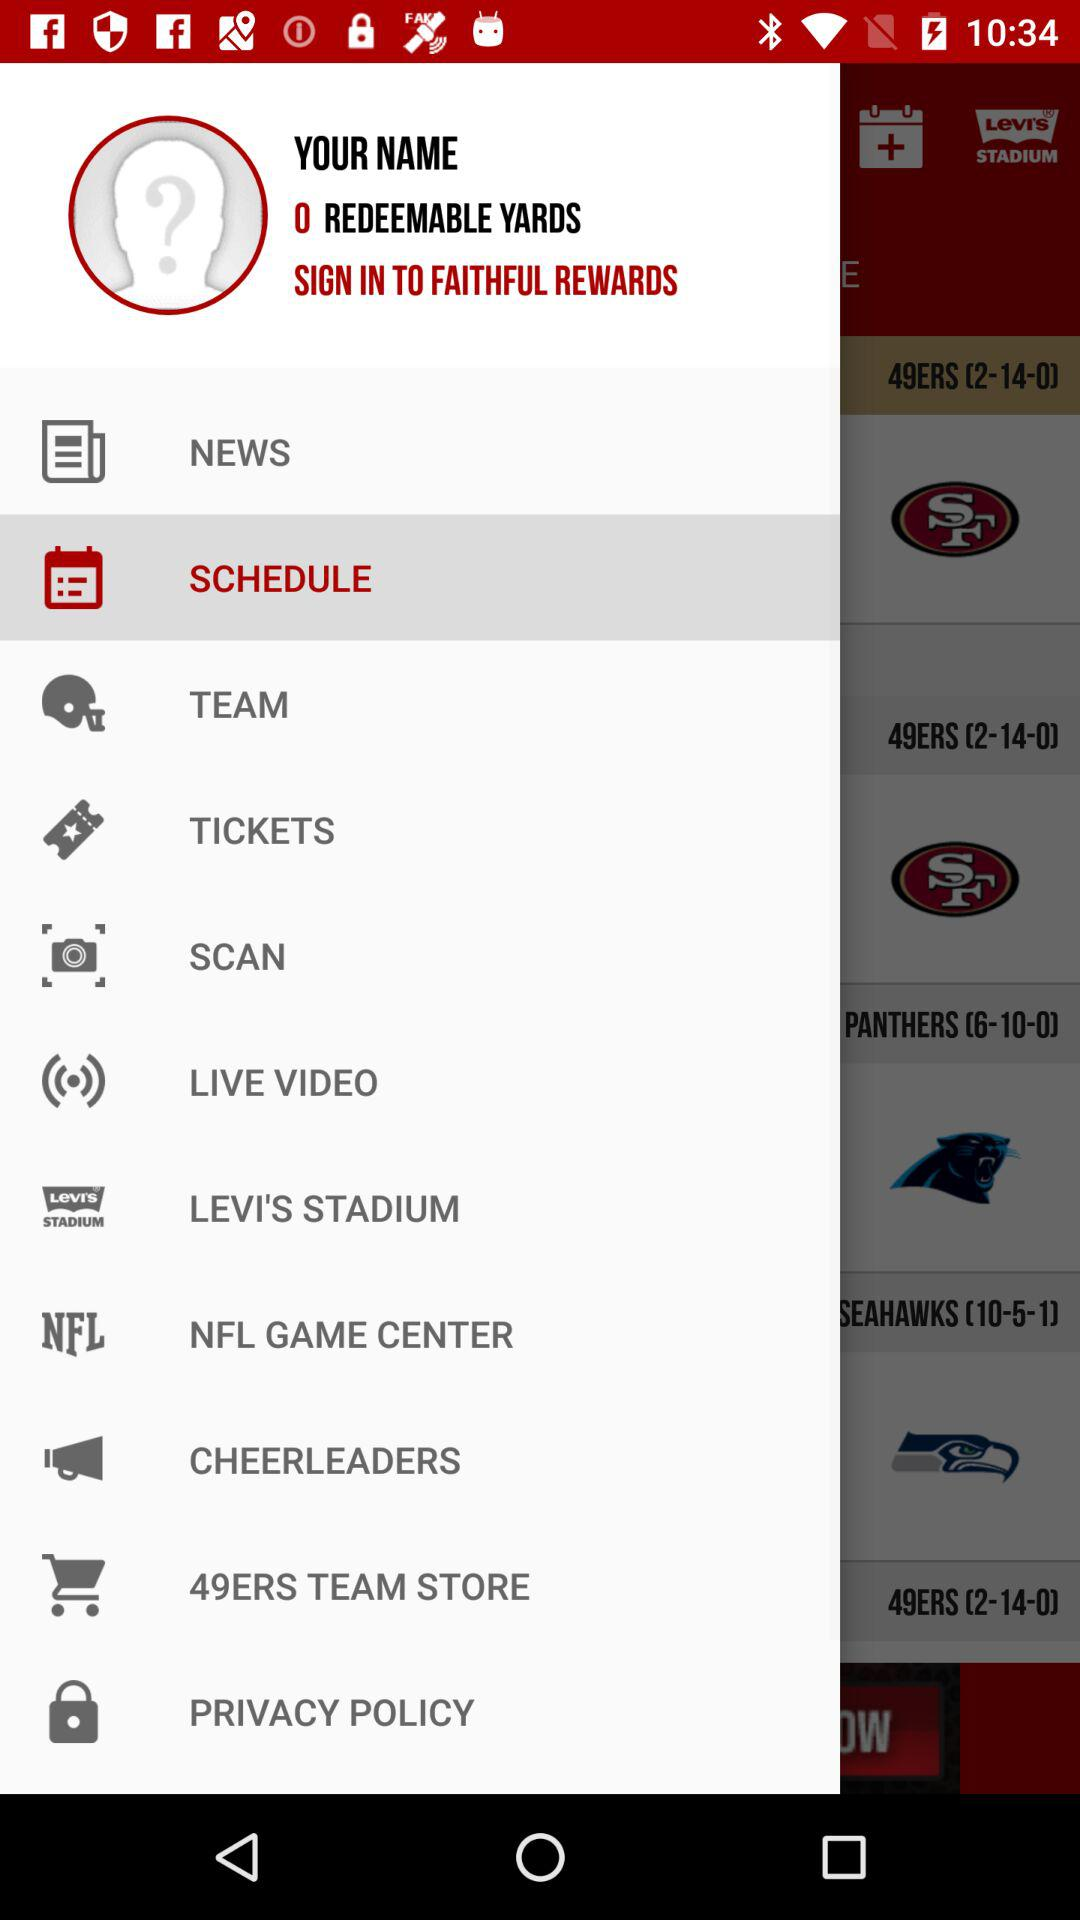Are there any redeemable yards?
When the provided information is insufficient, respond with <no answer>. <no answer> 